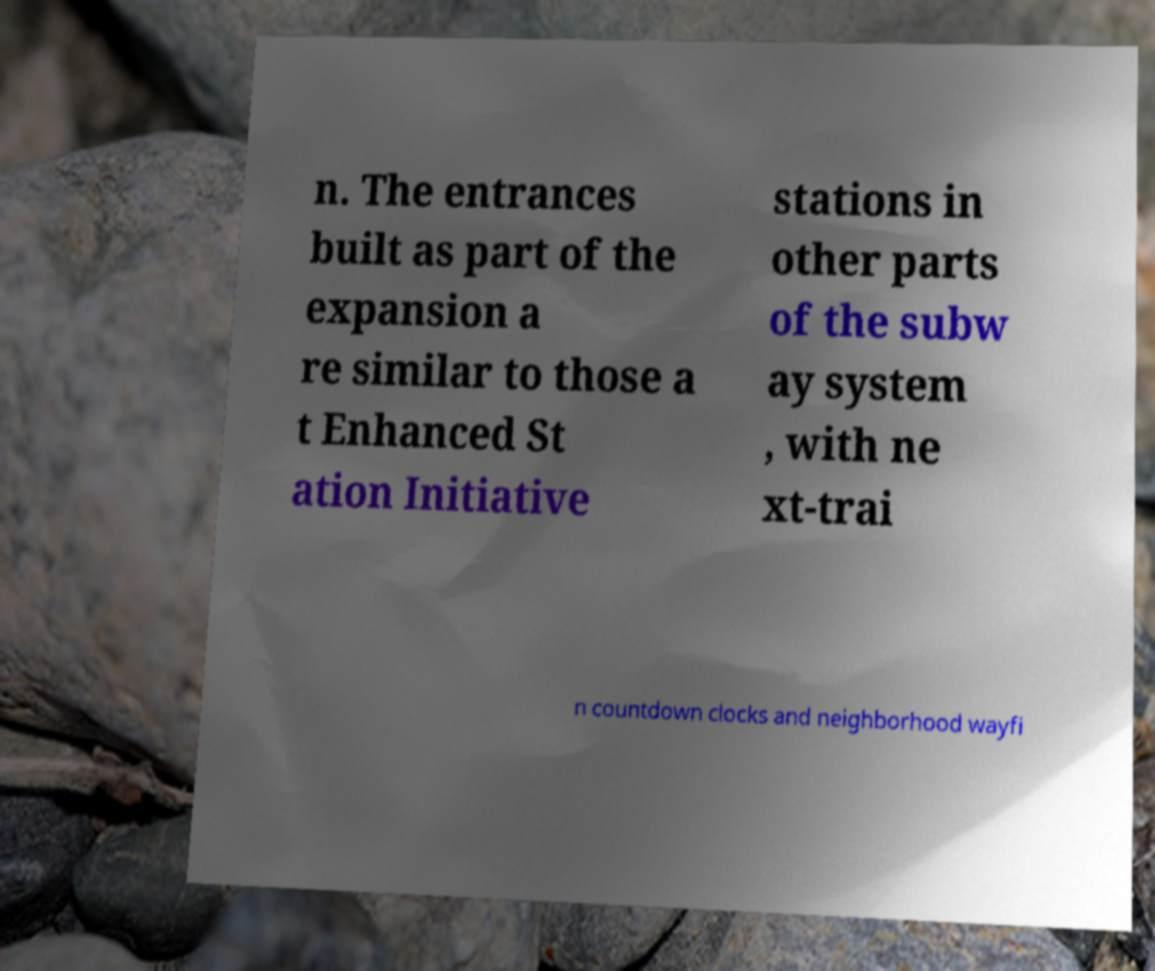I need the written content from this picture converted into text. Can you do that? n. The entrances built as part of the expansion a re similar to those a t Enhanced St ation Initiative stations in other parts of the subw ay system , with ne xt-trai n countdown clocks and neighborhood wayfi 